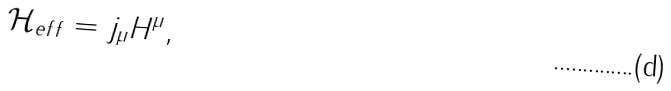<formula> <loc_0><loc_0><loc_500><loc_500>\mathcal { H } _ { e f f } = j _ { \mu } H ^ { \mu } ,</formula> 